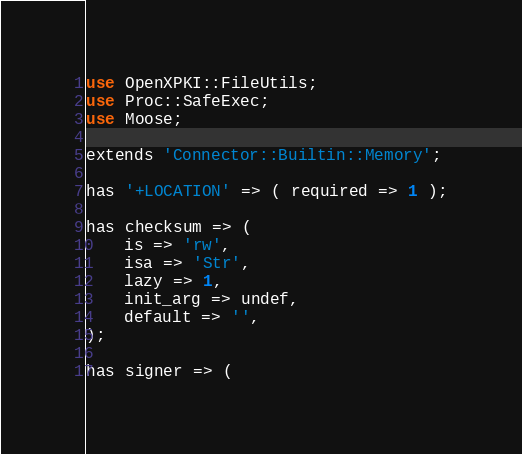<code> <loc_0><loc_0><loc_500><loc_500><_Perl_>use OpenXPKI::FileUtils;
use Proc::SafeExec;
use Moose;

extends 'Connector::Builtin::Memory';

has '+LOCATION' => ( required => 1 );

has checksum => (
    is => 'rw',
    isa => 'Str',
    lazy => 1,
    init_arg => undef,
    default => '',
);

has signer => (</code> 